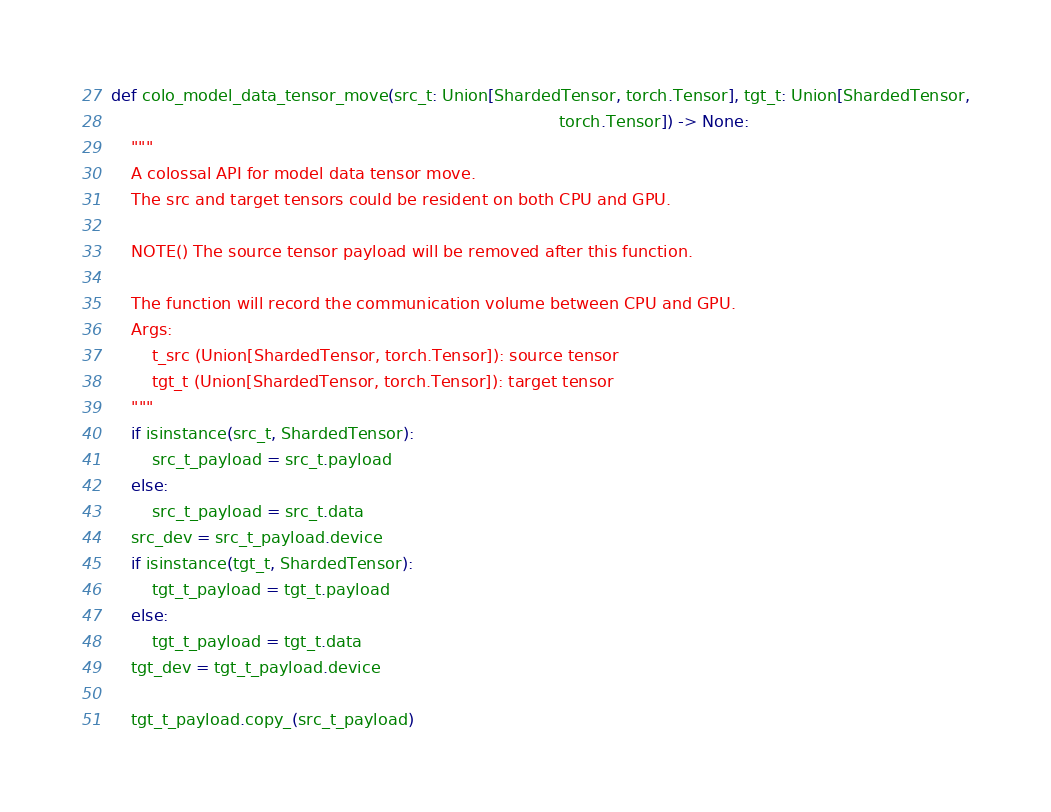Convert code to text. <code><loc_0><loc_0><loc_500><loc_500><_Python_>def colo_model_data_tensor_move(src_t: Union[ShardedTensor, torch.Tensor], tgt_t: Union[ShardedTensor,
                                                                                        torch.Tensor]) -> None:
    """ 
    A colossal API for model data tensor move. 
    The src and target tensors could be resident on both CPU and GPU.
    
    NOTE() The source tensor payload will be removed after this function.
    
    The function will record the communication volume between CPU and GPU.
    Args:
        t_src (Union[ShardedTensor, torch.Tensor]): source tensor
        tgt_t (Union[ShardedTensor, torch.Tensor]): target tensor
    """
    if isinstance(src_t, ShardedTensor):
        src_t_payload = src_t.payload
    else:
        src_t_payload = src_t.data
    src_dev = src_t_payload.device
    if isinstance(tgt_t, ShardedTensor):
        tgt_t_payload = tgt_t.payload
    else:
        tgt_t_payload = tgt_t.data
    tgt_dev = tgt_t_payload.device

    tgt_t_payload.copy_(src_t_payload)
</code> 